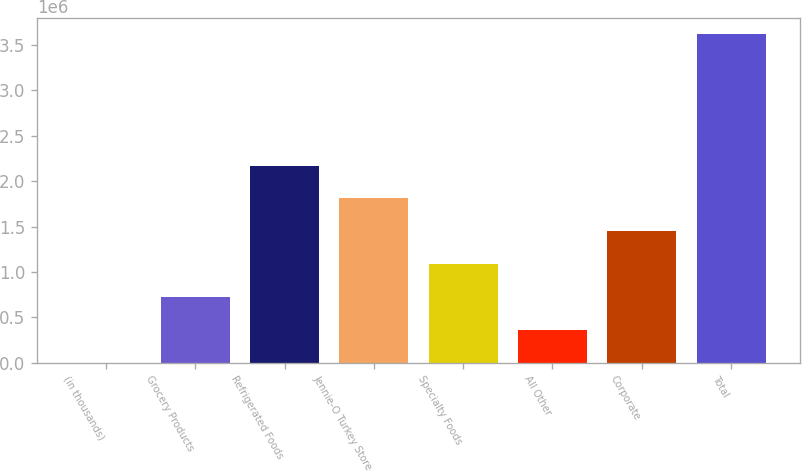<chart> <loc_0><loc_0><loc_500><loc_500><bar_chart><fcel>(in thousands)<fcel>Grocery Products<fcel>Refrigerated Foods<fcel>Jennie-O Turkey Store<fcel>Specialty Foods<fcel>All Other<fcel>Corporate<fcel>Total<nl><fcel>2008<fcel>724901<fcel>2.17069e+06<fcel>1.80924e+06<fcel>1.08635e+06<fcel>363454<fcel>1.44779e+06<fcel>3.61647e+06<nl></chart> 